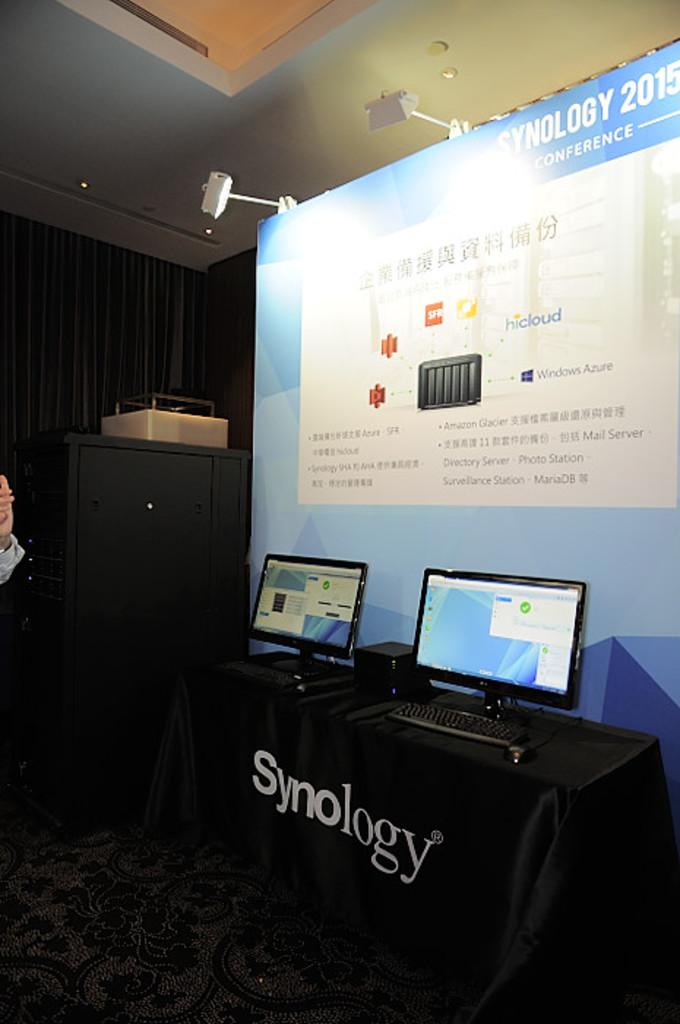Provide a one-sentence caption for the provided image. A Synology set up with two computers and a backdrop. 